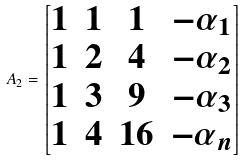Convert formula to latex. <formula><loc_0><loc_0><loc_500><loc_500>A _ { 2 } = \begin{bmatrix} 1 & 1 & 1 & - \alpha _ { 1 } \\ 1 & 2 & 4 & - \alpha _ { 2 } \\ 1 & 3 & 9 & - \alpha _ { 3 } \\ 1 & 4 & 1 6 & - \alpha _ { n } \end{bmatrix}</formula> 